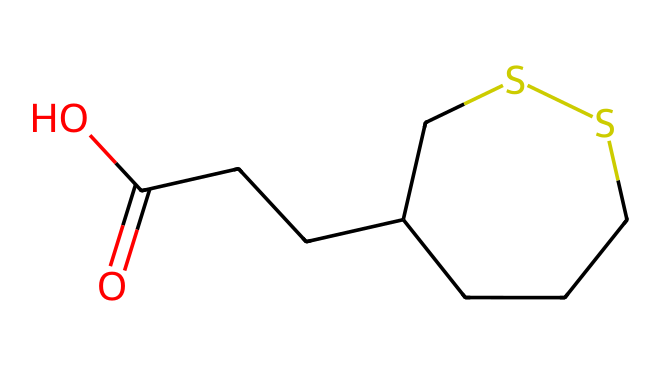what is the name of this compound? The SMILES representation indicates the presence of sulfur (S) along with the rest of the carbon structure typically associated with lipoic acid. Therefore, the name can be identified directly from the structure as lipoic acid.
Answer: lipoic acid how many carbon atoms are present in the structure? Counting the 'C' symbols in the SMILES representation reveals that there are 7 carbon atoms. Each 'C' represents a carbon atom, totaling up to 7.
Answer: 7 how many sulfur atoms are in this chemical? The SMILES representation includes two 'S' symbols, indicating that there are 2 sulfur atoms in the chemical structure. Each sulfur is accounted for in the visual representation.
Answer: 2 does this structure contain a carboxylic acid group? The presence of a 'C(=O)O' section in the chemical structure signifies a carboxylic acid group, identifiable by the carbon atom double bonded to an oxygen atom and single bonded to a hydroxyl group (O).
Answer: yes what type of antioxidant is lipoic acid categorized as? Given that lipoic acid has a structure that includes both sulfur and is recognized for its antioxidant properties, it is categorized as a free radical scavenger. The presence of sulfur in the structure plays a critical role in this function.
Answer: free radical scavenger how many double bonds are in this molecule? Analyzing the structure from the SMILES representation reveals only one double bond, specifically in the 'C(=O)' component, which shows the carbon is double bonded to an oxygen atom.
Answer: 1 is lipoic acid considered a vitamin? While lipoic acid acts similarly to vitamins in its role in metabolism and is significant for health, it is not classified as a vitamin because our body can synthesize it. The overall structure supports its biological function but does not fit the traditional definition of vitamins.
Answer: no 